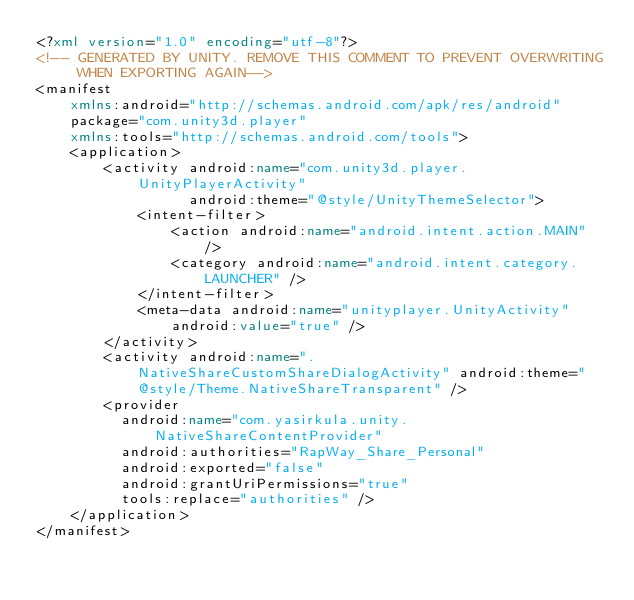<code> <loc_0><loc_0><loc_500><loc_500><_XML_><?xml version="1.0" encoding="utf-8"?>
<!-- GENERATED BY UNITY. REMOVE THIS COMMENT TO PREVENT OVERWRITING WHEN EXPORTING AGAIN-->
<manifest
    xmlns:android="http://schemas.android.com/apk/res/android"
    package="com.unity3d.player"
    xmlns:tools="http://schemas.android.com/tools">
    <application>
        <activity android:name="com.unity3d.player.UnityPlayerActivity"
                  android:theme="@style/UnityThemeSelector">
            <intent-filter>
                <action android:name="android.intent.action.MAIN" />
                <category android:name="android.intent.category.LAUNCHER" />
            </intent-filter>
            <meta-data android:name="unityplayer.UnityActivity" android:value="true" />
        </activity>
		<activity android:name=".NativeShareCustomShareDialogActivity" android:theme="@style/Theme.NativeShareTransparent" />
		<provider
		  android:name="com.yasirkula.unity.NativeShareContentProvider"
		  android:authorities="RapWay_Share_Personal"
		  android:exported="false"
		  android:grantUriPermissions="true"
          tools:replace="authorities" />
    </application>
</manifest>
</code> 